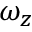<formula> <loc_0><loc_0><loc_500><loc_500>\omega _ { z }</formula> 